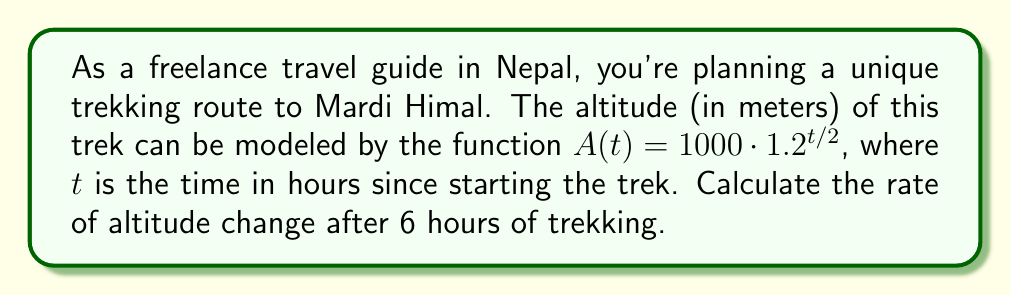Provide a solution to this math problem. To solve this problem, we need to use the concept of derivatives for exponential functions. The rate of change is given by the derivative of the altitude function with respect to time.

1) First, let's recall the general form of the derivative of an exponential function:
   If $f(x) = a \cdot b^x$, then $f'(x) = a \cdot b^x \cdot \ln(b)$

2) In our case, $A(t) = 1000 \cdot 1.2^{t/2}$. We can rewrite this as:
   $A(t) = 1000 \cdot (1.2^{1/2})^t = 1000 \cdot (\sqrt{1.2})^t$

3) Now we can apply the derivative rule:
   $A'(t) = 1000 \cdot (\sqrt{1.2})^t \cdot \ln(\sqrt{1.2})$

4) Simplify:
   $A'(t) = 1000 \cdot 1.2^{t/2} \cdot \frac{1}{2}\ln(1.2)$

5) To find the rate of change after 6 hours, we evaluate $A'(6)$:
   $A'(6) = 1000 \cdot 1.2^{6/2} \cdot \frac{1}{2}\ln(1.2)$
   $= 1000 \cdot 1.2^3 \cdot \frac{1}{2}\ln(1.2)$
   $\approx 1000 \cdot 1.728 \cdot 0.0912 \approx 157.5$

Therefore, after 6 hours of trekking, the rate of altitude change is approximately 157.5 meters per hour.
Answer: The rate of altitude change after 6 hours of trekking is approximately 157.5 meters per hour. 